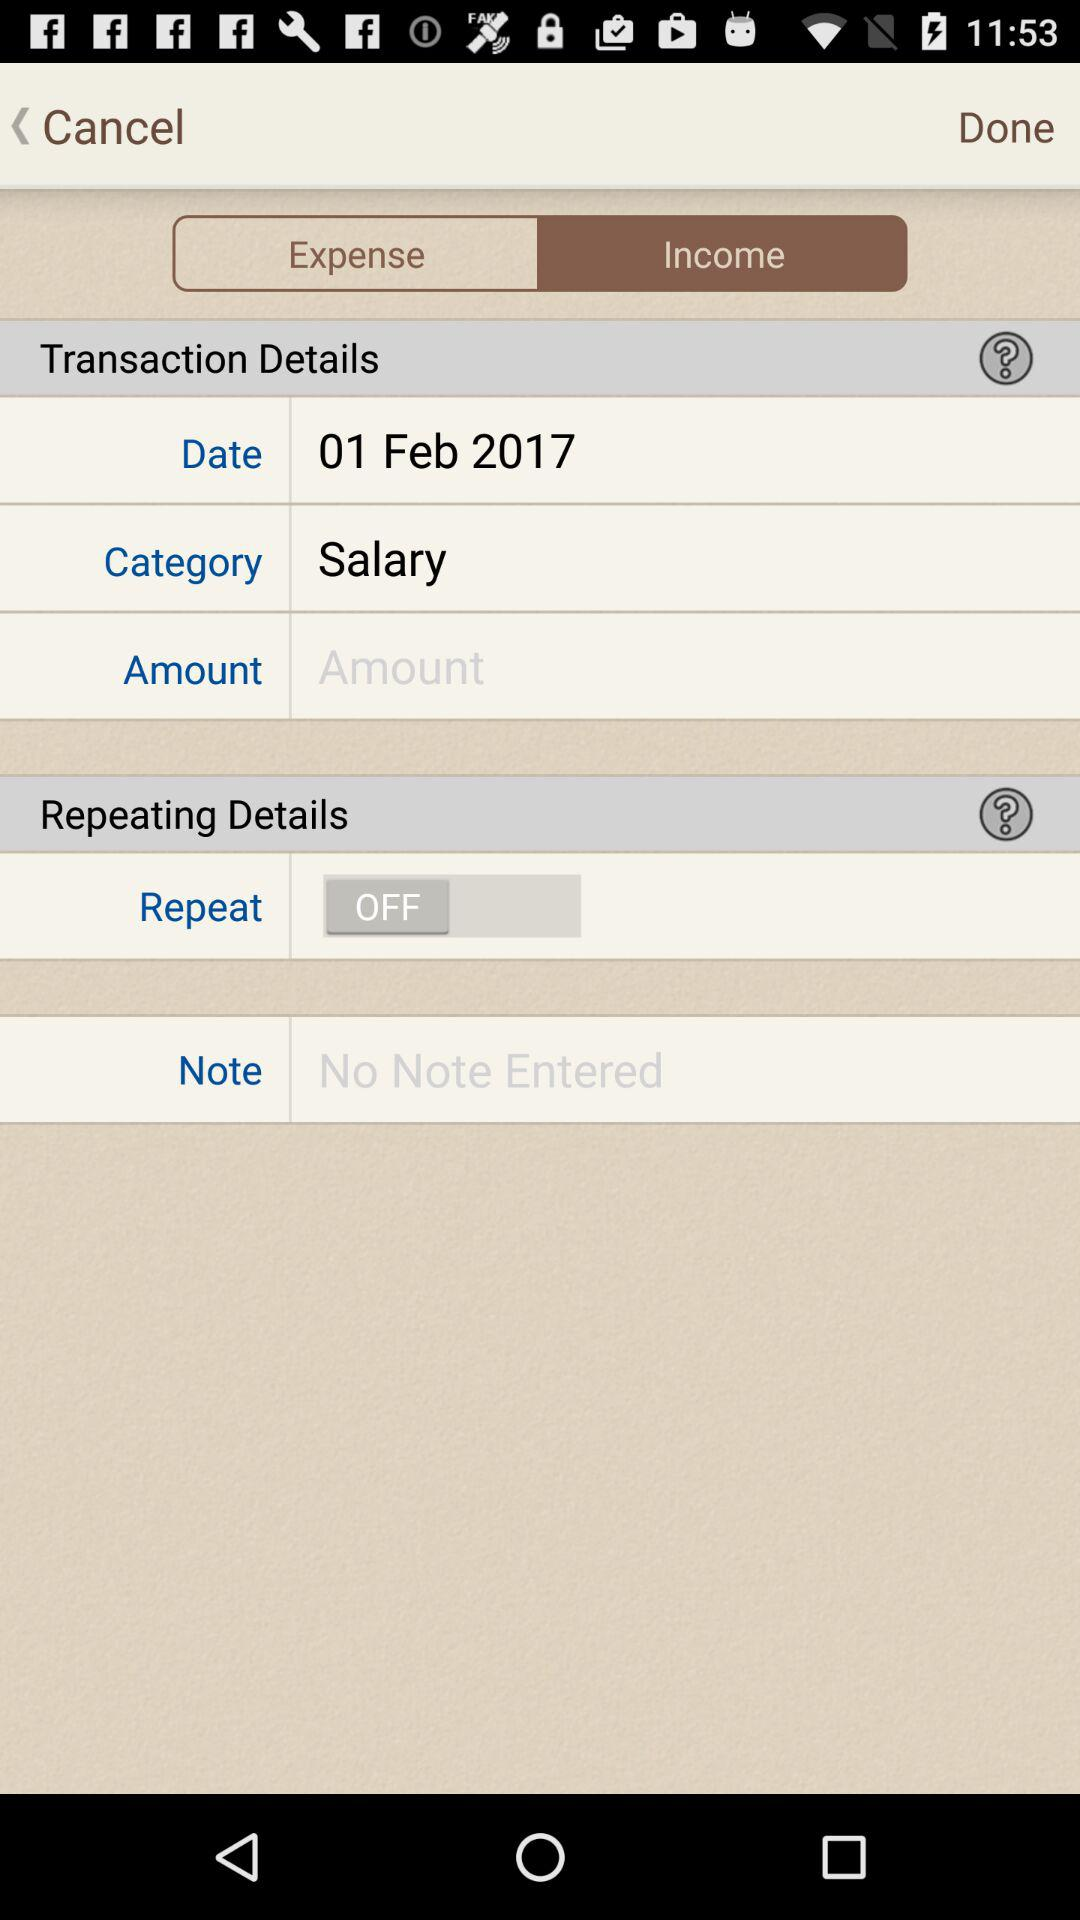What is the category? The category is "Salary". 